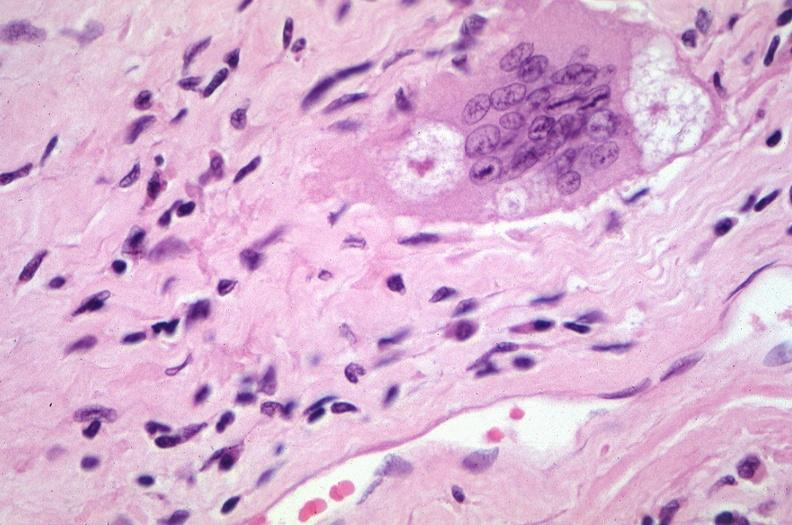how does this image show lung, sarcoidosis, multinucleated giant cells?
Answer the question using a single word or phrase. With asteroid bodies 